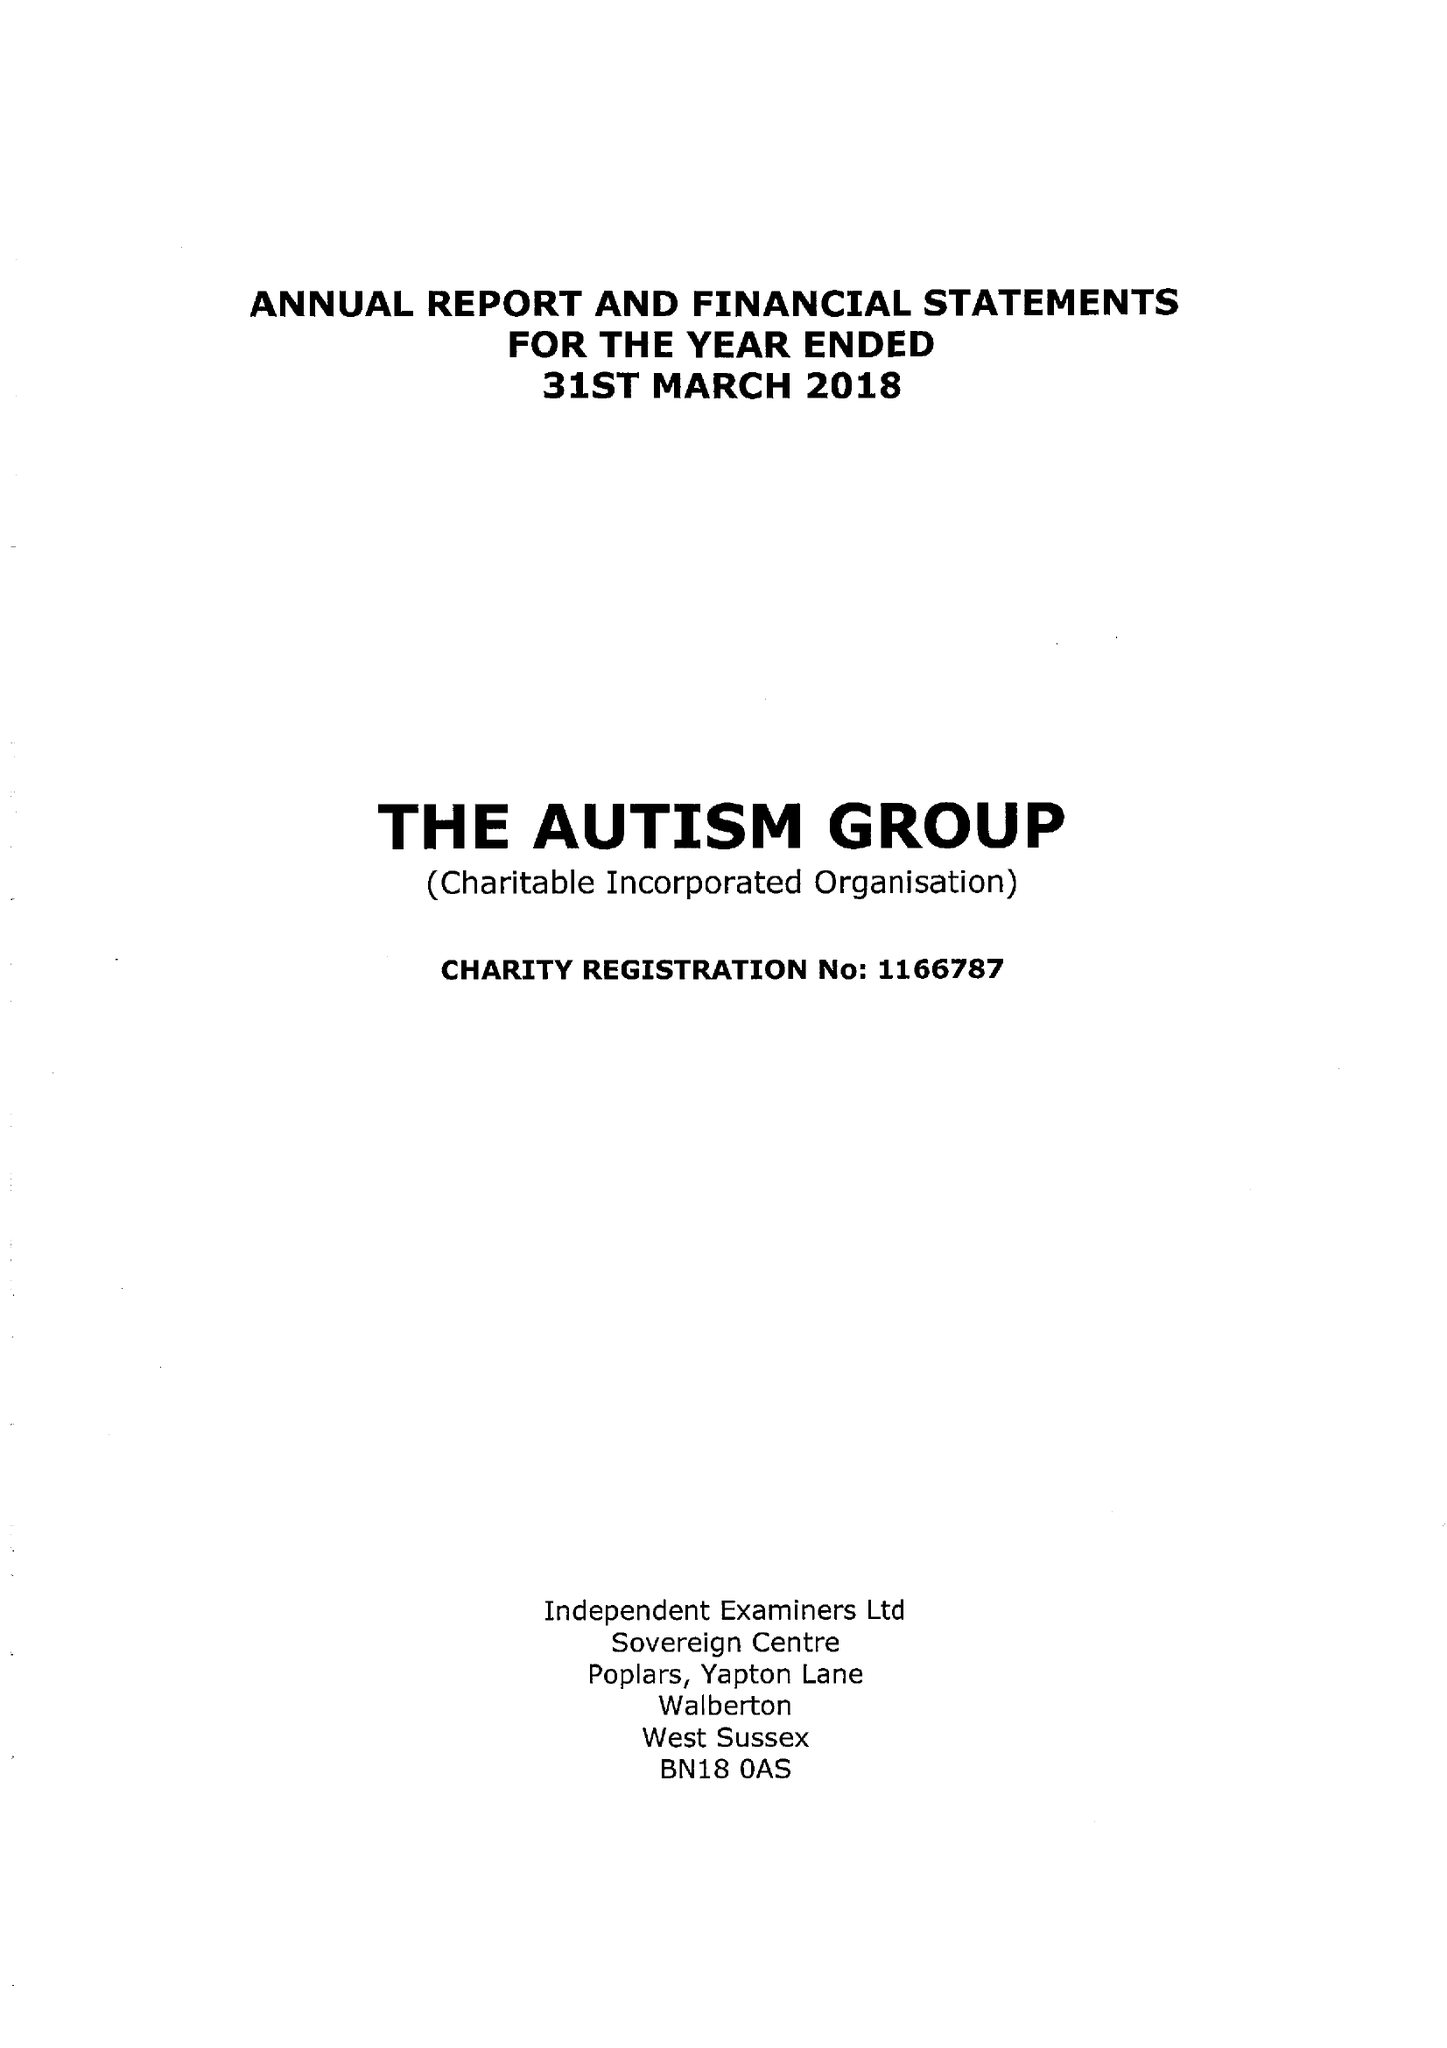What is the value for the charity_number?
Answer the question using a single word or phrase. 1166787 